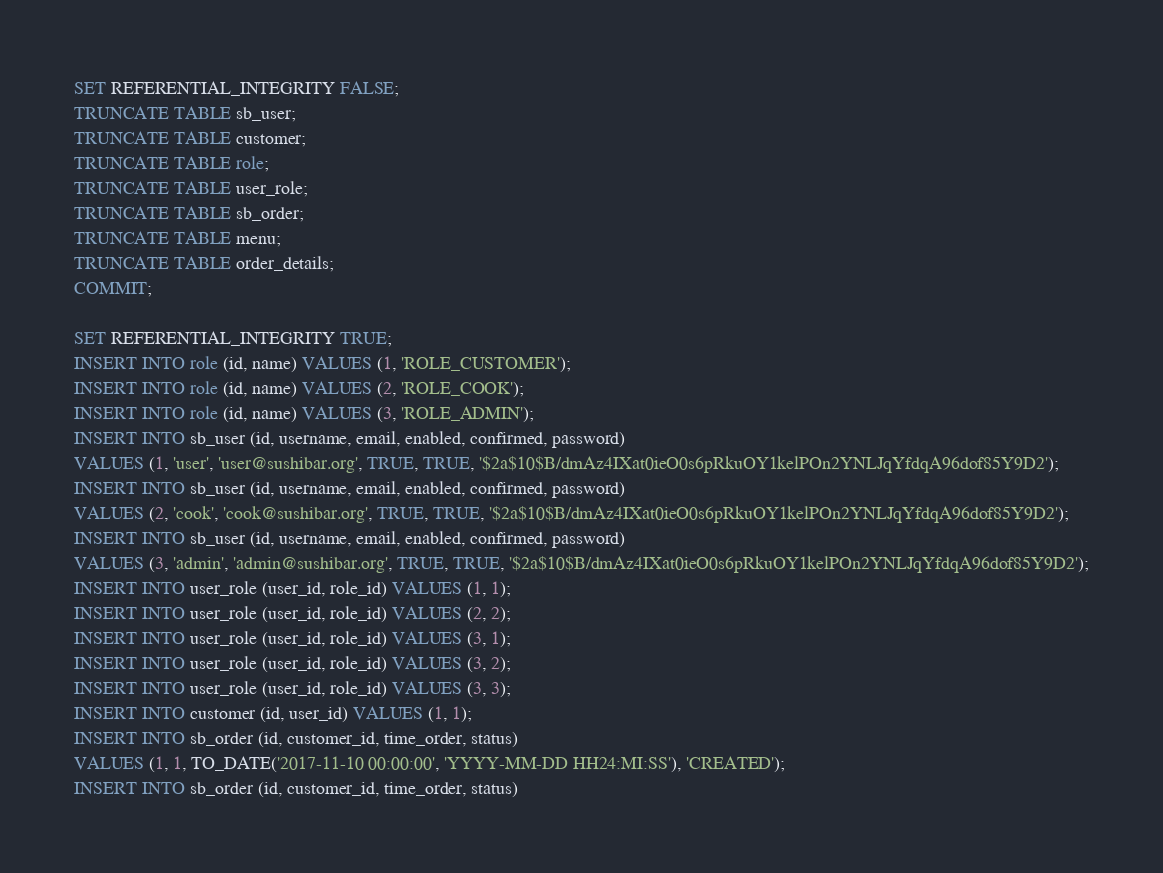<code> <loc_0><loc_0><loc_500><loc_500><_SQL_>SET REFERENTIAL_INTEGRITY FALSE;
TRUNCATE TABLE sb_user;
TRUNCATE TABLE customer;
TRUNCATE TABLE role;
TRUNCATE TABLE user_role;
TRUNCATE TABLE sb_order;
TRUNCATE TABLE menu;
TRUNCATE TABLE order_details;
COMMIT;

SET REFERENTIAL_INTEGRITY TRUE;
INSERT INTO role (id, name) VALUES (1, 'ROLE_CUSTOMER');
INSERT INTO role (id, name) VALUES (2, 'ROLE_COOK');
INSERT INTO role (id, name) VALUES (3, 'ROLE_ADMIN');
INSERT INTO sb_user (id, username, email, enabled, confirmed, password)
VALUES (1, 'user', 'user@sushibar.org', TRUE, TRUE, '$2a$10$B/dmAz4IXat0ieO0s6pRkuOY1kelPOn2YNLJqYfdqA96dof85Y9D2');
INSERT INTO sb_user (id, username, email, enabled, confirmed, password)
VALUES (2, 'cook', 'cook@sushibar.org', TRUE, TRUE, '$2a$10$B/dmAz4IXat0ieO0s6pRkuOY1kelPOn2YNLJqYfdqA96dof85Y9D2');
INSERT INTO sb_user (id, username, email, enabled, confirmed, password)
VALUES (3, 'admin', 'admin@sushibar.org', TRUE, TRUE, '$2a$10$B/dmAz4IXat0ieO0s6pRkuOY1kelPOn2YNLJqYfdqA96dof85Y9D2');
INSERT INTO user_role (user_id, role_id) VALUES (1, 1);
INSERT INTO user_role (user_id, role_id) VALUES (2, 2);
INSERT INTO user_role (user_id, role_id) VALUES (3, 1);
INSERT INTO user_role (user_id, role_id) VALUES (3, 2);
INSERT INTO user_role (user_id, role_id) VALUES (3, 3);
INSERT INTO customer (id, user_id) VALUES (1, 1);
INSERT INTO sb_order (id, customer_id, time_order, status)
VALUES (1, 1, TO_DATE('2017-11-10 00:00:00', 'YYYY-MM-DD HH24:MI:SS'), 'CREATED');
INSERT INTO sb_order (id, customer_id, time_order, status)</code> 